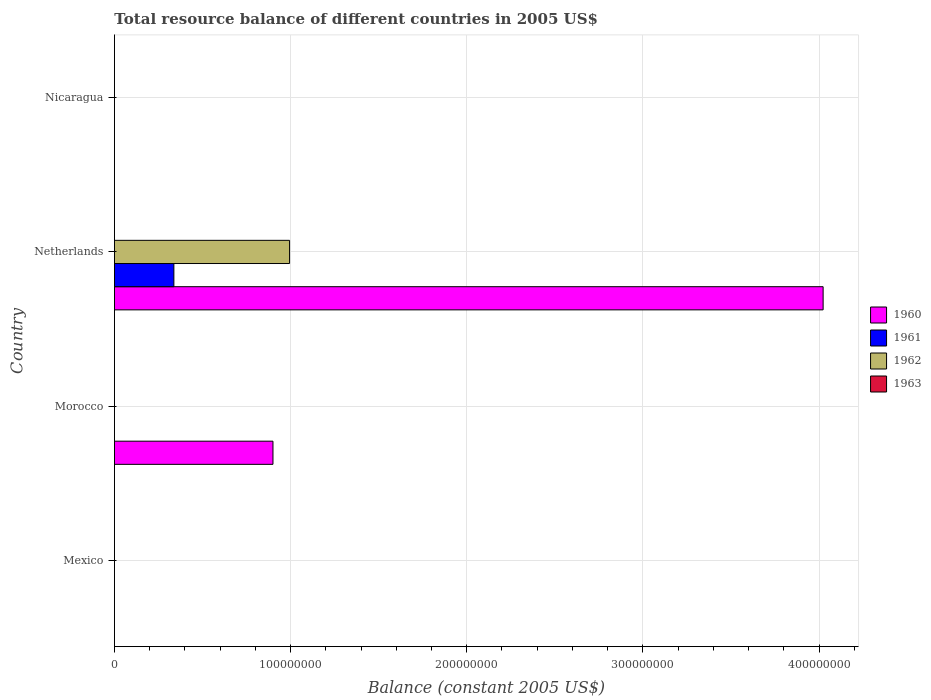Are the number of bars per tick equal to the number of legend labels?
Your response must be concise. No. Are the number of bars on each tick of the Y-axis equal?
Give a very brief answer. No. How many bars are there on the 2nd tick from the bottom?
Keep it short and to the point. 1. What is the label of the 4th group of bars from the top?
Offer a terse response. Mexico. Across all countries, what is the maximum total resource balance in 1961?
Your answer should be very brief. 3.37e+07. Across all countries, what is the minimum total resource balance in 1960?
Make the answer very short. 0. In which country was the total resource balance in 1961 maximum?
Your response must be concise. Netherlands. What is the total total resource balance in 1960 in the graph?
Ensure brevity in your answer.  4.92e+08. What is the difference between the total resource balance in 1960 in Morocco and the total resource balance in 1962 in Netherlands?
Offer a terse response. -9.42e+06. What is the difference between the total resource balance in 1962 and total resource balance in 1960 in Netherlands?
Your response must be concise. -3.03e+08. In how many countries, is the total resource balance in 1961 greater than 260000000 US$?
Your answer should be compact. 0. What is the difference between the highest and the lowest total resource balance in 1961?
Provide a succinct answer. 3.37e+07. Is it the case that in every country, the sum of the total resource balance in 1961 and total resource balance in 1963 is greater than the sum of total resource balance in 1960 and total resource balance in 1962?
Offer a very short reply. No. How many bars are there?
Your answer should be compact. 4. What is the difference between two consecutive major ticks on the X-axis?
Offer a very short reply. 1.00e+08. Does the graph contain any zero values?
Your answer should be very brief. Yes. Does the graph contain grids?
Make the answer very short. Yes. How are the legend labels stacked?
Offer a very short reply. Vertical. What is the title of the graph?
Provide a succinct answer. Total resource balance of different countries in 2005 US$. Does "1992" appear as one of the legend labels in the graph?
Provide a succinct answer. No. What is the label or title of the X-axis?
Offer a very short reply. Balance (constant 2005 US$). What is the label or title of the Y-axis?
Provide a succinct answer. Country. What is the Balance (constant 2005 US$) of 1960 in Mexico?
Your response must be concise. 0. What is the Balance (constant 2005 US$) of 1963 in Mexico?
Your answer should be very brief. 0. What is the Balance (constant 2005 US$) of 1960 in Morocco?
Your answer should be compact. 9.00e+07. What is the Balance (constant 2005 US$) of 1960 in Netherlands?
Offer a very short reply. 4.02e+08. What is the Balance (constant 2005 US$) of 1961 in Netherlands?
Provide a succinct answer. 3.37e+07. What is the Balance (constant 2005 US$) in 1962 in Netherlands?
Your response must be concise. 9.94e+07. What is the Balance (constant 2005 US$) in 1963 in Netherlands?
Your answer should be compact. 0. What is the Balance (constant 2005 US$) of 1960 in Nicaragua?
Offer a terse response. 0. What is the Balance (constant 2005 US$) of 1961 in Nicaragua?
Your response must be concise. 0. What is the Balance (constant 2005 US$) in 1963 in Nicaragua?
Keep it short and to the point. 0. Across all countries, what is the maximum Balance (constant 2005 US$) of 1960?
Offer a very short reply. 4.02e+08. Across all countries, what is the maximum Balance (constant 2005 US$) of 1961?
Your response must be concise. 3.37e+07. Across all countries, what is the maximum Balance (constant 2005 US$) in 1962?
Offer a terse response. 9.94e+07. Across all countries, what is the minimum Balance (constant 2005 US$) of 1961?
Make the answer very short. 0. Across all countries, what is the minimum Balance (constant 2005 US$) of 1962?
Keep it short and to the point. 0. What is the total Balance (constant 2005 US$) in 1960 in the graph?
Offer a terse response. 4.92e+08. What is the total Balance (constant 2005 US$) in 1961 in the graph?
Keep it short and to the point. 3.37e+07. What is the total Balance (constant 2005 US$) of 1962 in the graph?
Offer a terse response. 9.94e+07. What is the difference between the Balance (constant 2005 US$) of 1960 in Morocco and that in Netherlands?
Give a very brief answer. -3.12e+08. What is the difference between the Balance (constant 2005 US$) in 1960 in Morocco and the Balance (constant 2005 US$) in 1961 in Netherlands?
Your answer should be very brief. 5.63e+07. What is the difference between the Balance (constant 2005 US$) in 1960 in Morocco and the Balance (constant 2005 US$) in 1962 in Netherlands?
Provide a succinct answer. -9.42e+06. What is the average Balance (constant 2005 US$) of 1960 per country?
Make the answer very short. 1.23e+08. What is the average Balance (constant 2005 US$) in 1961 per country?
Your response must be concise. 8.44e+06. What is the average Balance (constant 2005 US$) in 1962 per country?
Ensure brevity in your answer.  2.49e+07. What is the difference between the Balance (constant 2005 US$) of 1960 and Balance (constant 2005 US$) of 1961 in Netherlands?
Make the answer very short. 3.69e+08. What is the difference between the Balance (constant 2005 US$) of 1960 and Balance (constant 2005 US$) of 1962 in Netherlands?
Your response must be concise. 3.03e+08. What is the difference between the Balance (constant 2005 US$) in 1961 and Balance (constant 2005 US$) in 1962 in Netherlands?
Give a very brief answer. -6.57e+07. What is the ratio of the Balance (constant 2005 US$) of 1960 in Morocco to that in Netherlands?
Give a very brief answer. 0.22. What is the difference between the highest and the lowest Balance (constant 2005 US$) of 1960?
Ensure brevity in your answer.  4.02e+08. What is the difference between the highest and the lowest Balance (constant 2005 US$) in 1961?
Offer a terse response. 3.37e+07. What is the difference between the highest and the lowest Balance (constant 2005 US$) of 1962?
Your response must be concise. 9.94e+07. 